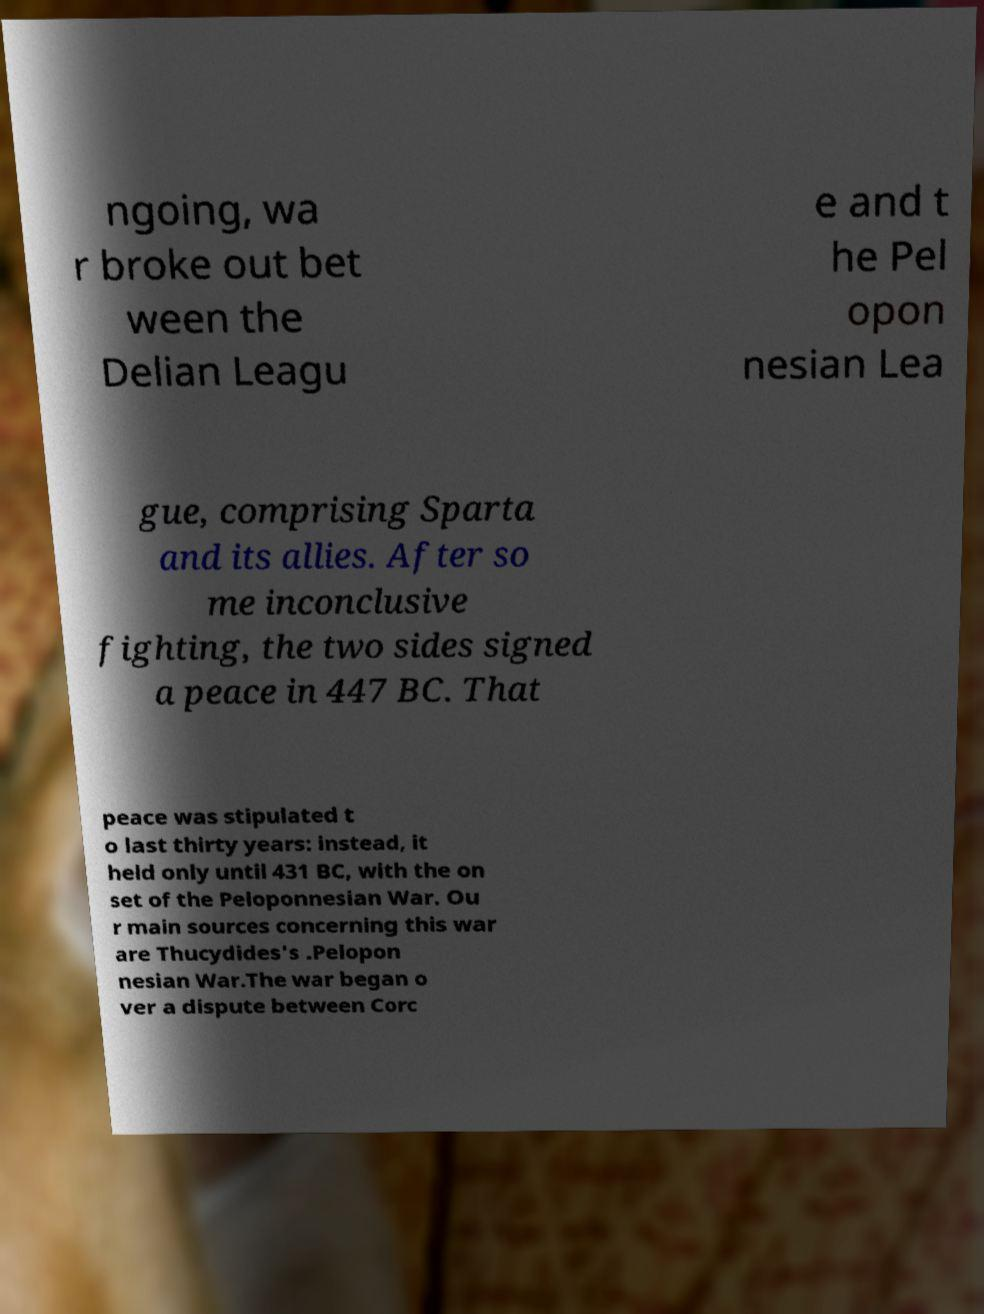There's text embedded in this image that I need extracted. Can you transcribe it verbatim? ngoing, wa r broke out bet ween the Delian Leagu e and t he Pel opon nesian Lea gue, comprising Sparta and its allies. After so me inconclusive fighting, the two sides signed a peace in 447 BC. That peace was stipulated t o last thirty years: instead, it held only until 431 BC, with the on set of the Peloponnesian War. Ou r main sources concerning this war are Thucydides's .Pelopon nesian War.The war began o ver a dispute between Corc 